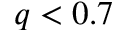<formula> <loc_0><loc_0><loc_500><loc_500>q < 0 . 7</formula> 